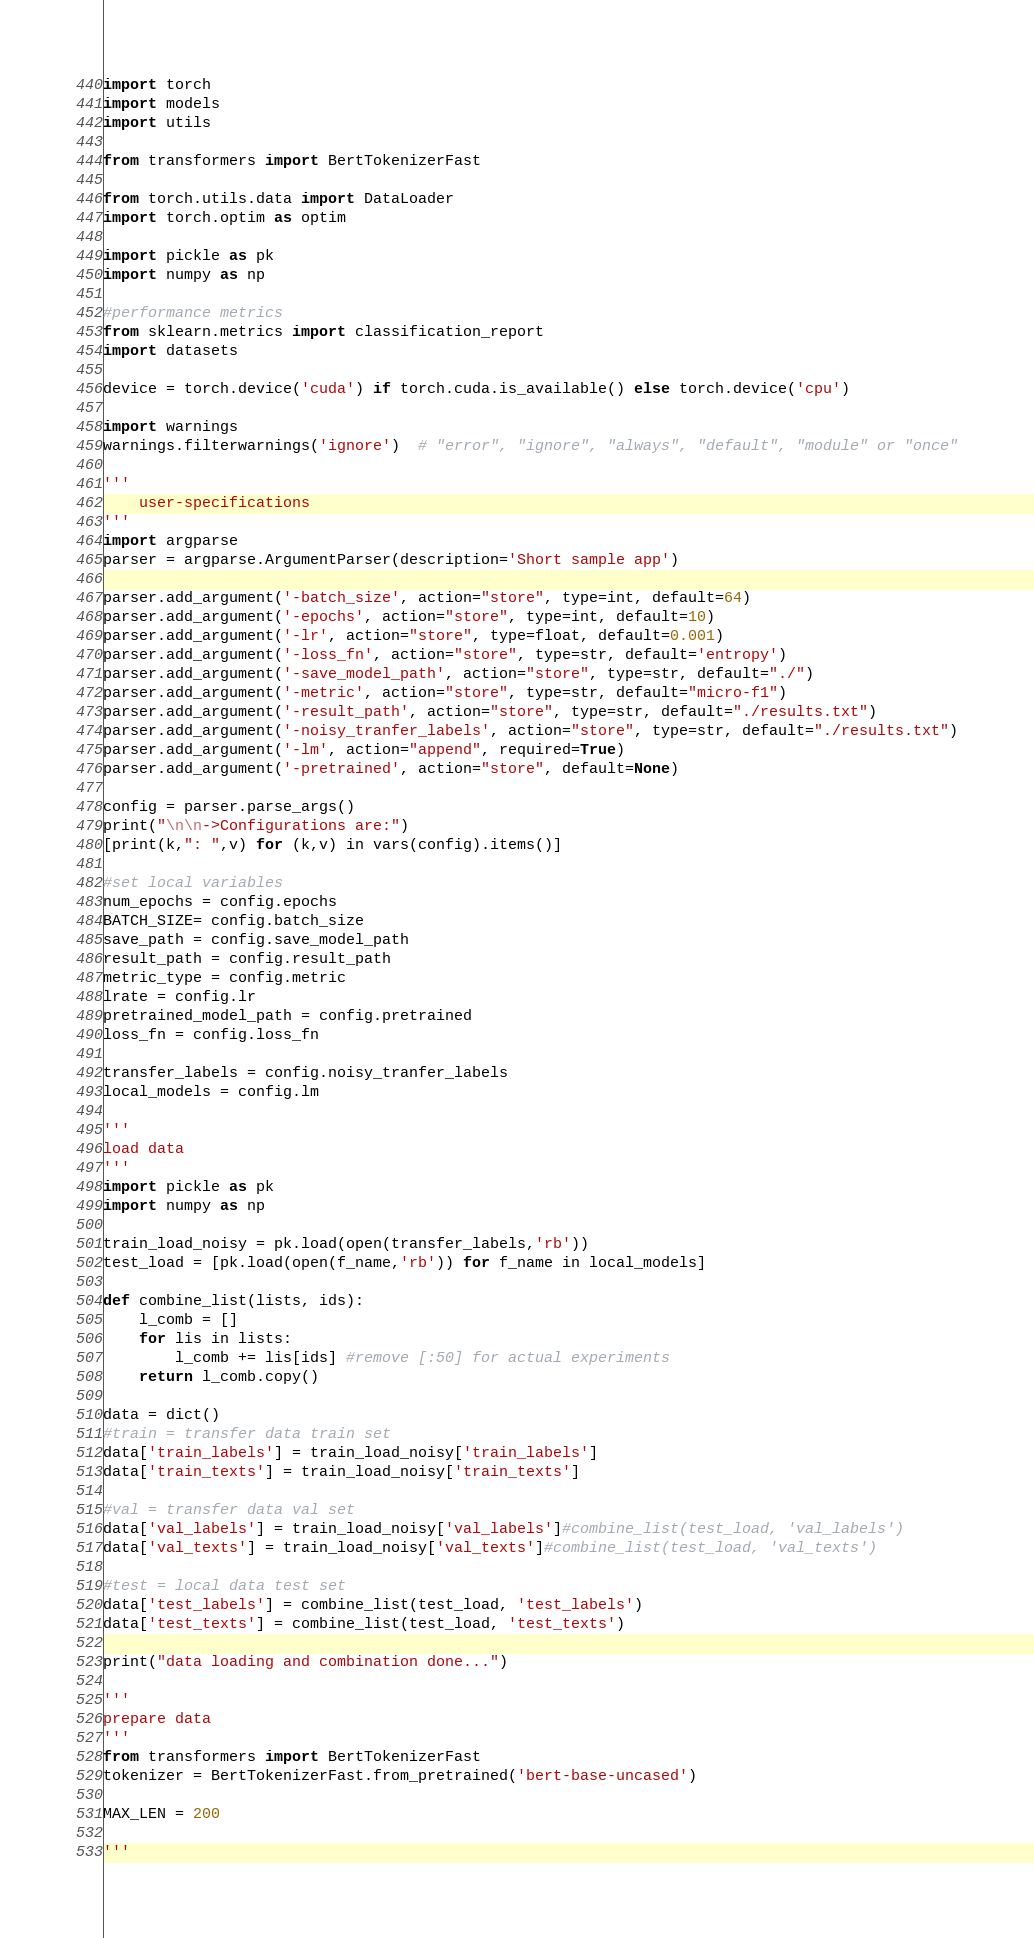Convert code to text. <code><loc_0><loc_0><loc_500><loc_500><_Python_>import torch
import models
import utils

from transformers import BertTokenizerFast

from torch.utils.data import DataLoader
import torch.optim as optim

import pickle as pk
import numpy as np

#performance metrics
from sklearn.metrics import classification_report
import datasets

device = torch.device('cuda') if torch.cuda.is_available() else torch.device('cpu')

import warnings
warnings.filterwarnings('ignore')  # "error", "ignore", "always", "default", "module" or "once"

'''
    user-specifications
'''
import argparse
parser = argparse.ArgumentParser(description='Short sample app')

parser.add_argument('-batch_size', action="store", type=int, default=64)
parser.add_argument('-epochs', action="store", type=int, default=10)
parser.add_argument('-lr', action="store", type=float, default=0.001)
parser.add_argument('-loss_fn', action="store", type=str, default='entropy')
parser.add_argument('-save_model_path', action="store", type=str, default="./")
parser.add_argument('-metric', action="store", type=str, default="micro-f1")
parser.add_argument('-result_path', action="store", type=str, default="./results.txt")
parser.add_argument('-noisy_tranfer_labels', action="store", type=str, default="./results.txt")
parser.add_argument('-lm', action="append", required=True)
parser.add_argument('-pretrained', action="store", default=None)

config = parser.parse_args()
print("\n\n->Configurations are:")
[print(k,": ",v) for (k,v) in vars(config).items()]

#set local variables
num_epochs = config.epochs
BATCH_SIZE= config.batch_size
save_path = config.save_model_path
result_path = config.result_path
metric_type = config.metric
lrate = config.lr
pretrained_model_path = config.pretrained
loss_fn = config.loss_fn

transfer_labels = config.noisy_tranfer_labels
local_models = config.lm

'''
load data
'''
import pickle as pk
import numpy as np

train_load_noisy = pk.load(open(transfer_labels,'rb'))
test_load = [pk.load(open(f_name,'rb')) for f_name in local_models]

def combine_list(lists, ids):
    l_comb = []
    for lis in lists:
        l_comb += lis[ids] #remove [:50] for actual experiments
    return l_comb.copy()

data = dict()
#train = transfer data train set
data['train_labels'] = train_load_noisy['train_labels']
data['train_texts'] = train_load_noisy['train_texts']

#val = transfer data val set 
data['val_labels'] = train_load_noisy['val_labels']#combine_list(test_load, 'val_labels')
data['val_texts'] = train_load_noisy['val_texts']#combine_list(test_load, 'val_texts')

#test = local data test set
data['test_labels'] = combine_list(test_load, 'test_labels')
data['test_texts'] = combine_list(test_load, 'test_texts')

print("data loading and combination done...")

'''
prepare data
'''
from transformers import BertTokenizerFast
tokenizer = BertTokenizerFast.from_pretrained('bert-base-uncased')

MAX_LEN = 200

'''</code> 